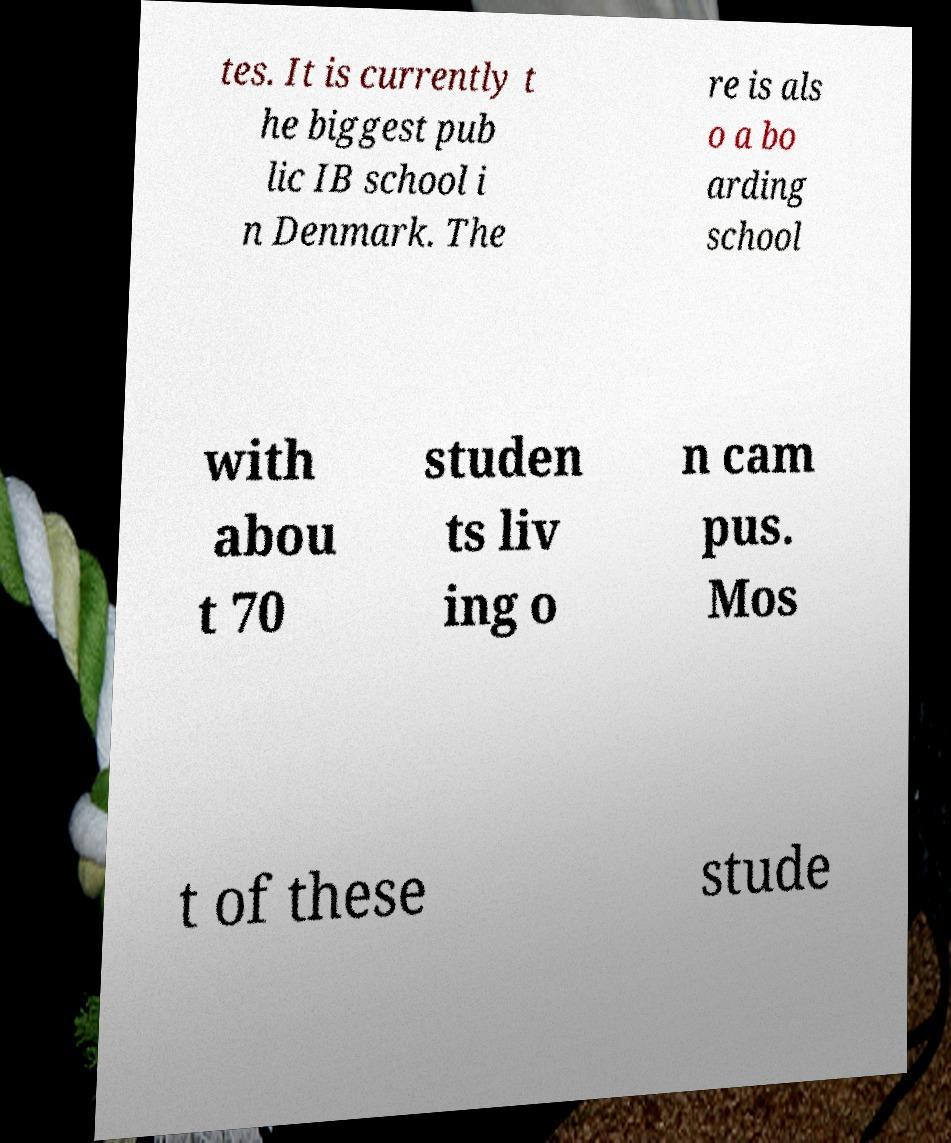What messages or text are displayed in this image? I need them in a readable, typed format. tes. It is currently t he biggest pub lic IB school i n Denmark. The re is als o a bo arding school with abou t 70 studen ts liv ing o n cam pus. Mos t of these stude 